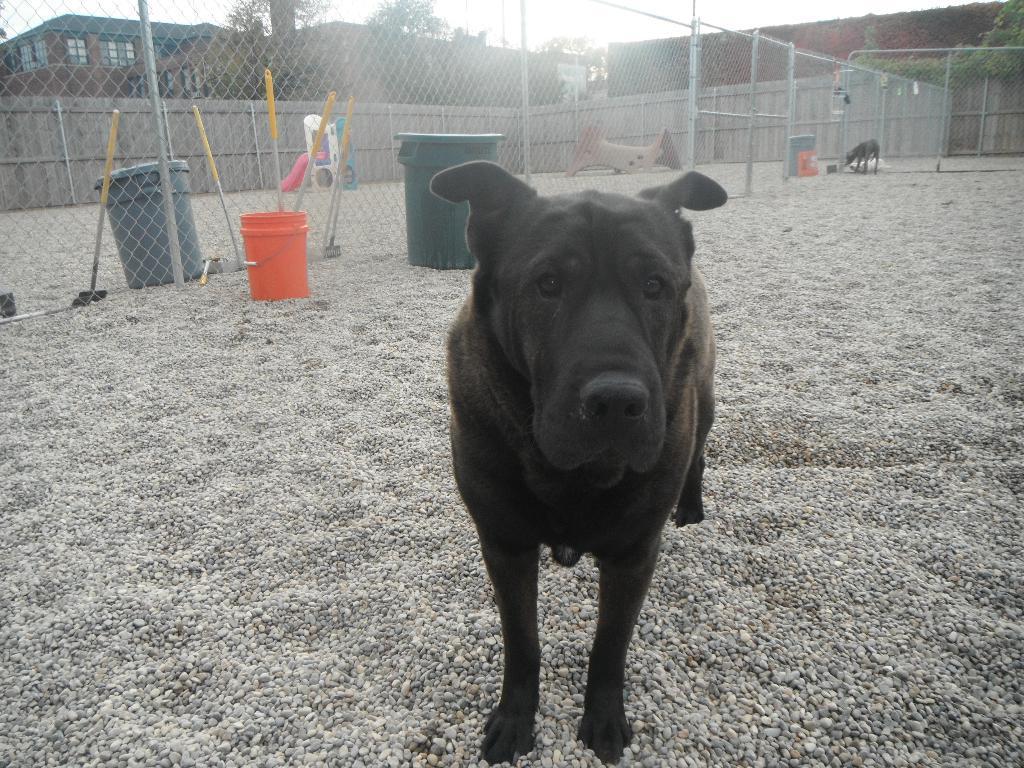Describe this image in one or two sentences. In the image we can see a dog, black in color. This is a sand, container, fence, plant, building and windows of the building, and a sky. We can even see there is another animal. 